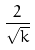<formula> <loc_0><loc_0><loc_500><loc_500>\frac { 2 } { \sqrt { k } }</formula> 